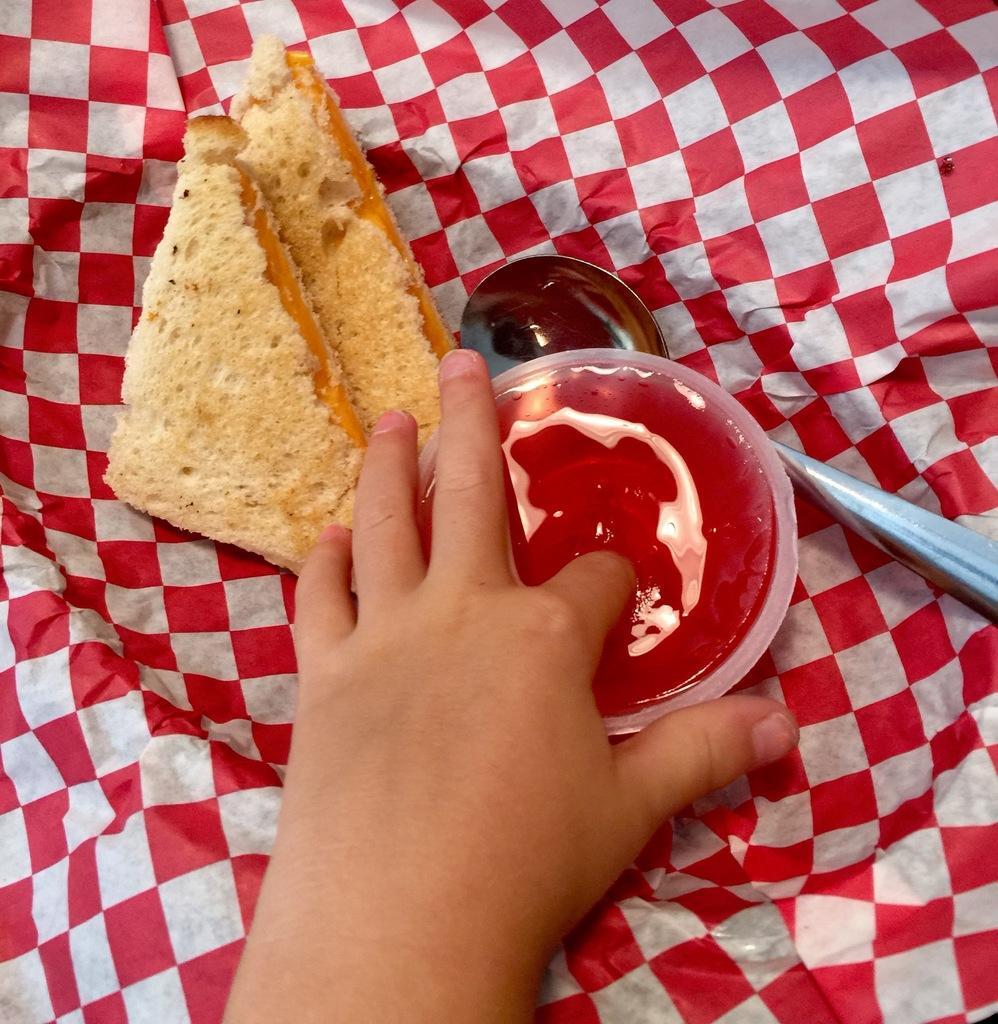Can you describe this image briefly? In this image we can see a person's hand and also we can see some bread pieces, spoon and a cup on the cloth. 